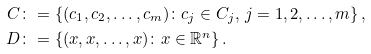Convert formula to latex. <formula><loc_0><loc_0><loc_500><loc_500>C & \colon = \left \{ ( c _ { 1 } , c _ { 2 } , \dots , c _ { m } ) \colon c _ { j } \in C _ { j } , \, j = 1 , 2 , \dots , m \right \} , \\ D & \colon = \left \{ ( x , x , \dots , x ) \colon x \in \mathbb { R } ^ { n } \right \} .</formula> 